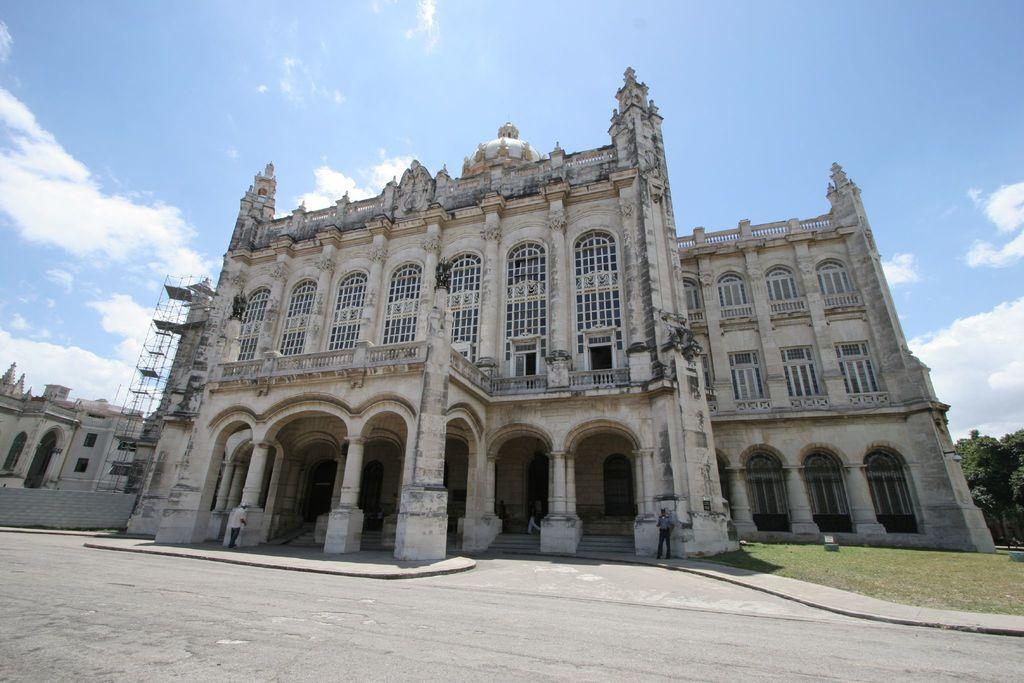Can you describe this image briefly? In this picture we can see a building. There are few arches on this building. Some grass is visible on the ground. There are two people on the path.. We can see some trees on the left side. 